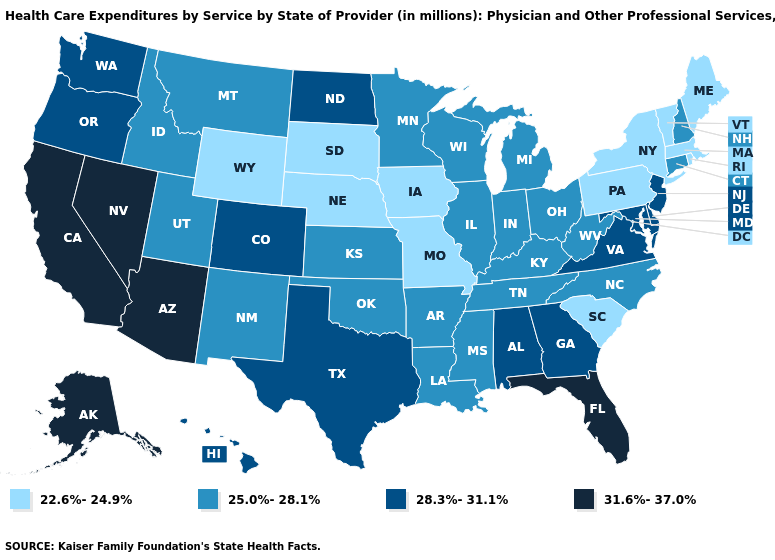Among the states that border Oklahoma , does Missouri have the lowest value?
Concise answer only. Yes. Which states hav the highest value in the West?
Concise answer only. Alaska, Arizona, California, Nevada. Does Wyoming have the lowest value in the West?
Concise answer only. Yes. How many symbols are there in the legend?
Write a very short answer. 4. What is the value of North Carolina?
Be succinct. 25.0%-28.1%. What is the lowest value in states that border Montana?
Quick response, please. 22.6%-24.9%. What is the lowest value in the West?
Short answer required. 22.6%-24.9%. What is the value of Rhode Island?
Give a very brief answer. 22.6%-24.9%. Name the states that have a value in the range 25.0%-28.1%?
Short answer required. Arkansas, Connecticut, Idaho, Illinois, Indiana, Kansas, Kentucky, Louisiana, Michigan, Minnesota, Mississippi, Montana, New Hampshire, New Mexico, North Carolina, Ohio, Oklahoma, Tennessee, Utah, West Virginia, Wisconsin. Name the states that have a value in the range 22.6%-24.9%?
Answer briefly. Iowa, Maine, Massachusetts, Missouri, Nebraska, New York, Pennsylvania, Rhode Island, South Carolina, South Dakota, Vermont, Wyoming. Does North Dakota have the highest value in the MidWest?
Answer briefly. Yes. What is the value of Oregon?
Give a very brief answer. 28.3%-31.1%. Which states hav the highest value in the Northeast?
Give a very brief answer. New Jersey. Does Pennsylvania have the lowest value in the USA?
Be succinct. Yes. What is the value of New Hampshire?
Be succinct. 25.0%-28.1%. 